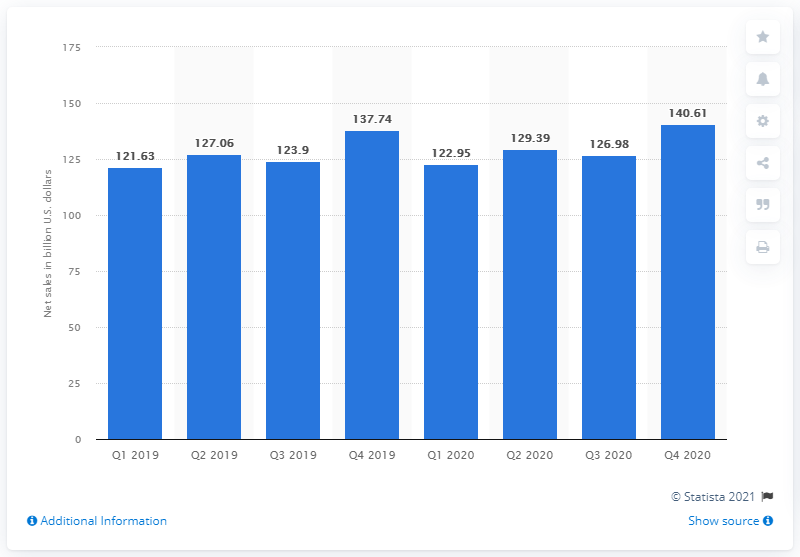Give some essential details in this illustration. In the fourth quarter of 2020, Walmart's net sales were 140.61 billion dollars. 